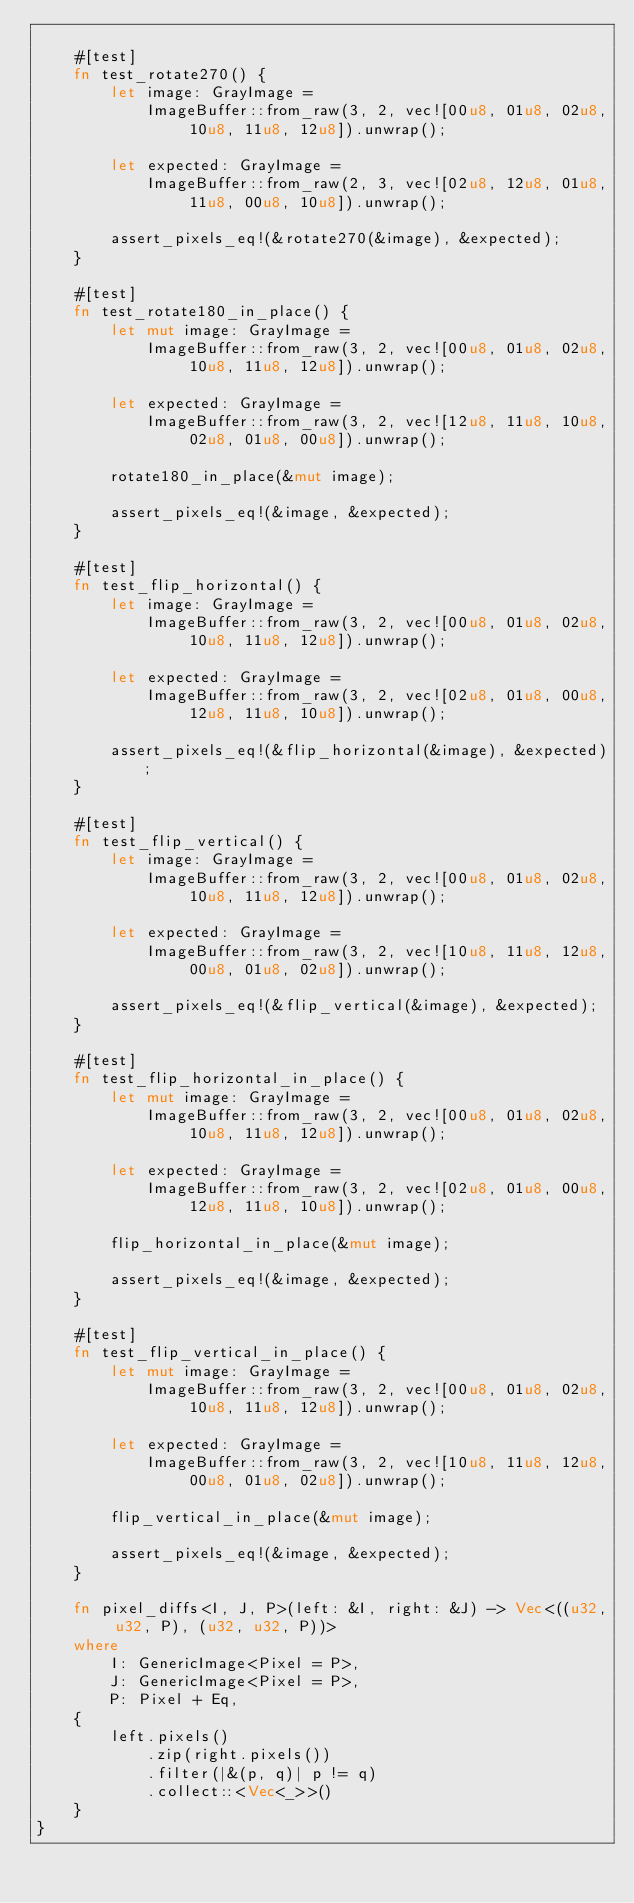<code> <loc_0><loc_0><loc_500><loc_500><_Rust_>
    #[test]
    fn test_rotate270() {
        let image: GrayImage =
            ImageBuffer::from_raw(3, 2, vec![00u8, 01u8, 02u8, 10u8, 11u8, 12u8]).unwrap();

        let expected: GrayImage =
            ImageBuffer::from_raw(2, 3, vec![02u8, 12u8, 01u8, 11u8, 00u8, 10u8]).unwrap();

        assert_pixels_eq!(&rotate270(&image), &expected);
    }

    #[test]
    fn test_rotate180_in_place() {
        let mut image: GrayImage =
            ImageBuffer::from_raw(3, 2, vec![00u8, 01u8, 02u8, 10u8, 11u8, 12u8]).unwrap();

        let expected: GrayImage =
            ImageBuffer::from_raw(3, 2, vec![12u8, 11u8, 10u8, 02u8, 01u8, 00u8]).unwrap();

        rotate180_in_place(&mut image);

        assert_pixels_eq!(&image, &expected);
    }

    #[test]
    fn test_flip_horizontal() {
        let image: GrayImage =
            ImageBuffer::from_raw(3, 2, vec![00u8, 01u8, 02u8, 10u8, 11u8, 12u8]).unwrap();

        let expected: GrayImage =
            ImageBuffer::from_raw(3, 2, vec![02u8, 01u8, 00u8, 12u8, 11u8, 10u8]).unwrap();

        assert_pixels_eq!(&flip_horizontal(&image), &expected);
    }

    #[test]
    fn test_flip_vertical() {
        let image: GrayImage =
            ImageBuffer::from_raw(3, 2, vec![00u8, 01u8, 02u8, 10u8, 11u8, 12u8]).unwrap();

        let expected: GrayImage =
            ImageBuffer::from_raw(3, 2, vec![10u8, 11u8, 12u8, 00u8, 01u8, 02u8]).unwrap();

        assert_pixels_eq!(&flip_vertical(&image), &expected);
    }

    #[test]
    fn test_flip_horizontal_in_place() {
        let mut image: GrayImage =
            ImageBuffer::from_raw(3, 2, vec![00u8, 01u8, 02u8, 10u8, 11u8, 12u8]).unwrap();

        let expected: GrayImage =
            ImageBuffer::from_raw(3, 2, vec![02u8, 01u8, 00u8, 12u8, 11u8, 10u8]).unwrap();

        flip_horizontal_in_place(&mut image);

        assert_pixels_eq!(&image, &expected);
    }

    #[test]
    fn test_flip_vertical_in_place() {
        let mut image: GrayImage =
            ImageBuffer::from_raw(3, 2, vec![00u8, 01u8, 02u8, 10u8, 11u8, 12u8]).unwrap();

        let expected: GrayImage =
            ImageBuffer::from_raw(3, 2, vec![10u8, 11u8, 12u8, 00u8, 01u8, 02u8]).unwrap();

        flip_vertical_in_place(&mut image);

        assert_pixels_eq!(&image, &expected);
    }

    fn pixel_diffs<I, J, P>(left: &I, right: &J) -> Vec<((u32, u32, P), (u32, u32, P))>
    where
        I: GenericImage<Pixel = P>,
        J: GenericImage<Pixel = P>,
        P: Pixel + Eq,
    {
        left.pixels()
            .zip(right.pixels())
            .filter(|&(p, q)| p != q)
            .collect::<Vec<_>>()
    }
}
</code> 